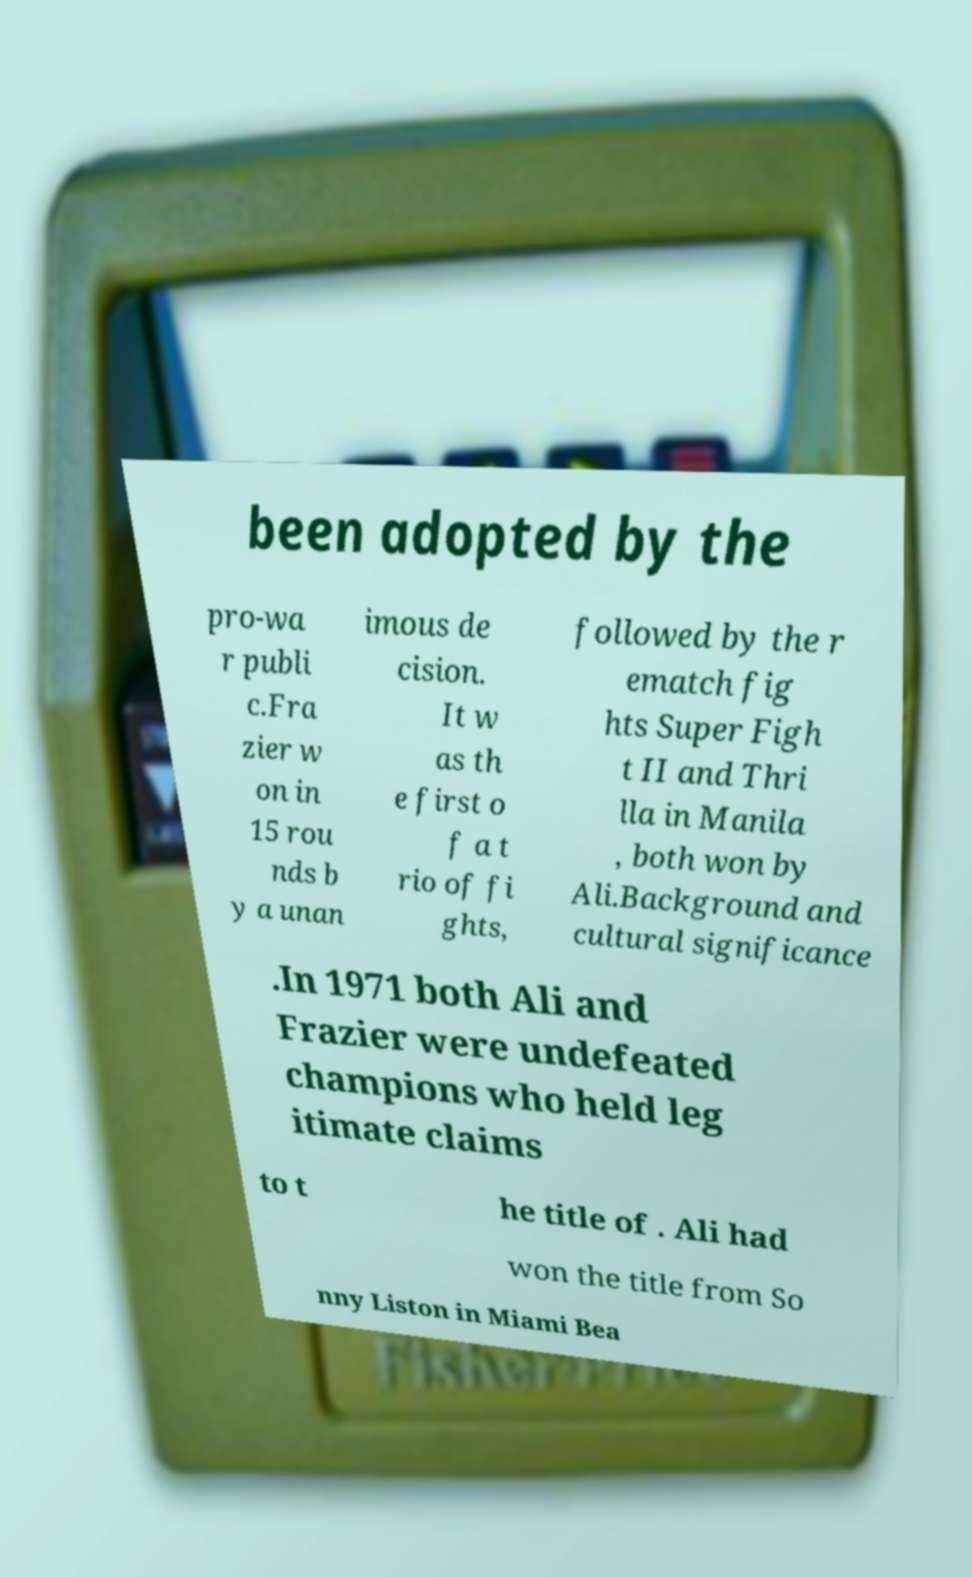Can you read and provide the text displayed in the image?This photo seems to have some interesting text. Can you extract and type it out for me? been adopted by the pro-wa r publi c.Fra zier w on in 15 rou nds b y a unan imous de cision. It w as th e first o f a t rio of fi ghts, followed by the r ematch fig hts Super Figh t II and Thri lla in Manila , both won by Ali.Background and cultural significance .In 1971 both Ali and Frazier were undefeated champions who held leg itimate claims to t he title of . Ali had won the title from So nny Liston in Miami Bea 